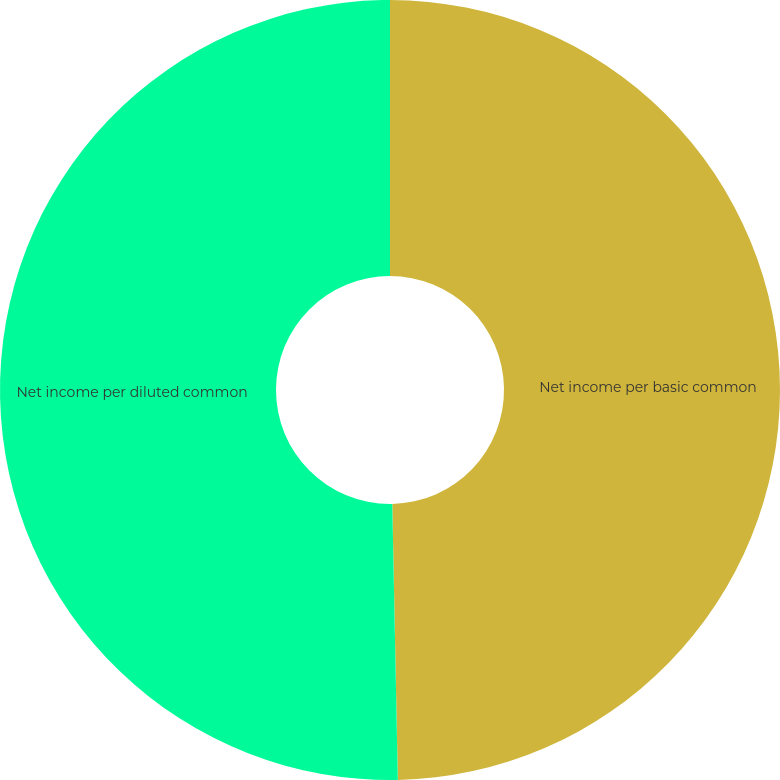Convert chart to OTSL. <chart><loc_0><loc_0><loc_500><loc_500><pie_chart><fcel>Net income per basic common<fcel>Net income per diluted common<nl><fcel>49.68%<fcel>50.32%<nl></chart> 